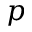<formula> <loc_0><loc_0><loc_500><loc_500>p</formula> 